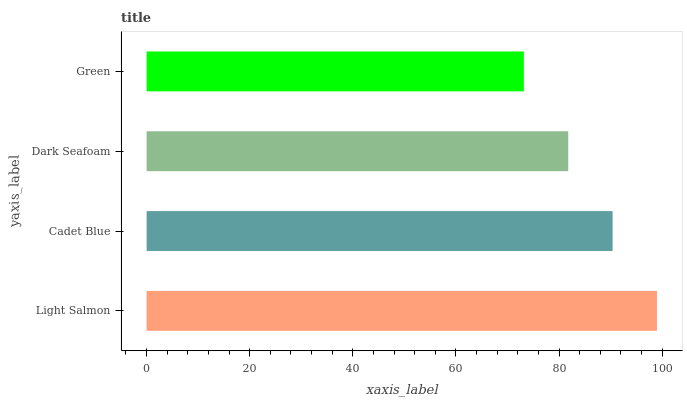Is Green the minimum?
Answer yes or no. Yes. Is Light Salmon the maximum?
Answer yes or no. Yes. Is Cadet Blue the minimum?
Answer yes or no. No. Is Cadet Blue the maximum?
Answer yes or no. No. Is Light Salmon greater than Cadet Blue?
Answer yes or no. Yes. Is Cadet Blue less than Light Salmon?
Answer yes or no. Yes. Is Cadet Blue greater than Light Salmon?
Answer yes or no. No. Is Light Salmon less than Cadet Blue?
Answer yes or no. No. Is Cadet Blue the high median?
Answer yes or no. Yes. Is Dark Seafoam the low median?
Answer yes or no. Yes. Is Dark Seafoam the high median?
Answer yes or no. No. Is Green the low median?
Answer yes or no. No. 